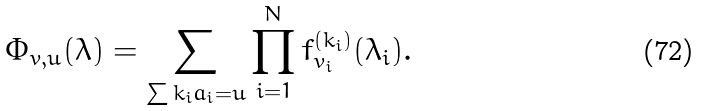Convert formula to latex. <formula><loc_0><loc_0><loc_500><loc_500>\Phi _ { v , u } ( \lambda ) = \sum _ { \sum k _ { i } { a } _ { i } = u } \prod _ { i = 1 } ^ { N } f _ { v _ { i } } ^ { ( k _ { i } ) } ( \lambda _ { i } ) .</formula> 